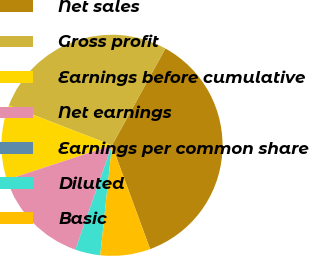Convert chart. <chart><loc_0><loc_0><loc_500><loc_500><pie_chart><fcel>Net sales<fcel>Gross profit<fcel>Earnings before cumulative<fcel>Net earnings<fcel>Earnings per common share<fcel>Diluted<fcel>Basic<nl><fcel>36.36%<fcel>27.15%<fcel>10.93%<fcel>14.56%<fcel>0.03%<fcel>3.66%<fcel>7.3%<nl></chart> 